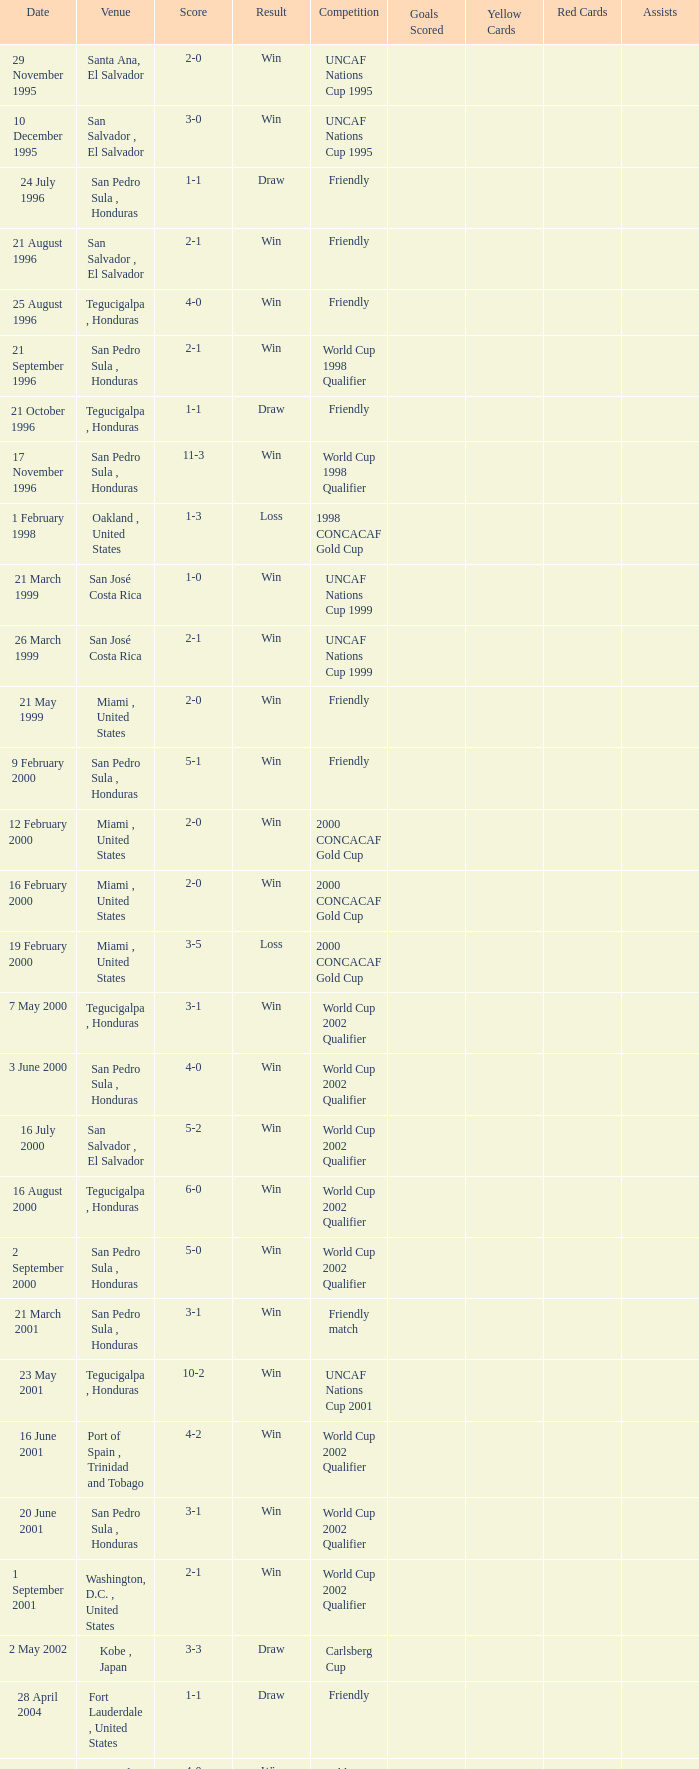What is the date of the uncaf nations cup 2009? 26 January 2009. 